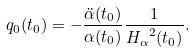Convert formula to latex. <formula><loc_0><loc_0><loc_500><loc_500>q _ { 0 } ( t _ { 0 } ) = - { \frac { { \ddot { \alpha } } ( t _ { 0 } ) } { \alpha ( t _ { 0 } ) } } { \frac { 1 } { { H _ { \alpha } } ^ { 2 } ( t _ { 0 } ) } } .</formula> 